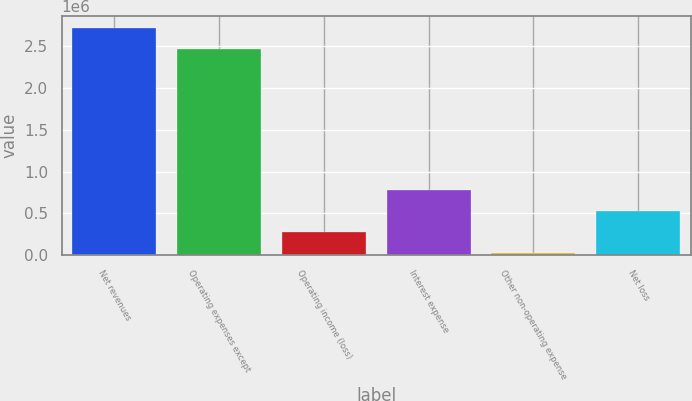Convert chart. <chart><loc_0><loc_0><loc_500><loc_500><bar_chart><fcel>Net revenues<fcel>Operating expenses except<fcel>Operating income (loss)<fcel>Interest expense<fcel>Other non-operating expense<fcel>Net loss<nl><fcel>2.72594e+06<fcel>2.47267e+06<fcel>279152<fcel>785702<fcel>25876<fcel>532427<nl></chart> 